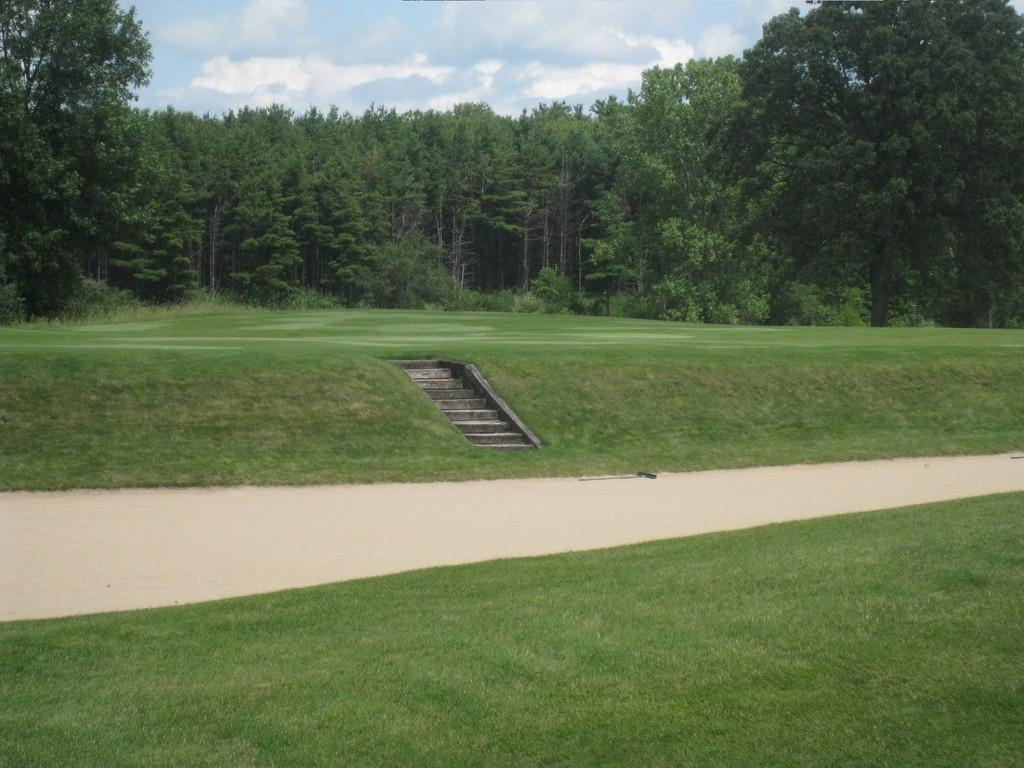What can be seen in the foreground of the picture? In the foreground of the picture, there is a path, a staircase, and grass. What is visible in the background of the picture? In the background of the picture, there are trees, plants, and grass. How is the sky depicted in the image? The sky is depicted as cloudy in the image. What type of toy can be seen hanging from the tree in the background? There is no toy present in the image; the background features trees, plants, and grass. Can you hear a whistle in the image? There is no sound depicted in the image, so it is not possible to determine if a whistle can be heard. 